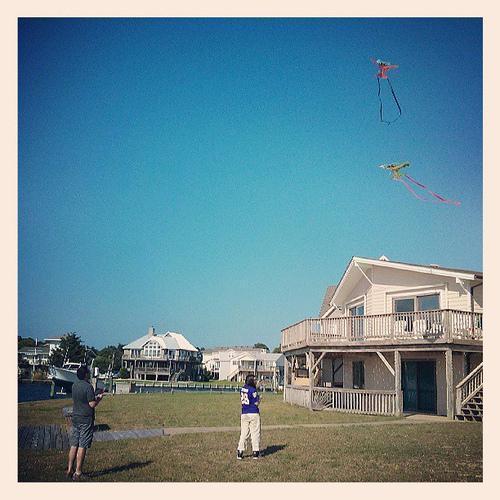How many people are seen?
Give a very brief answer. 2. 